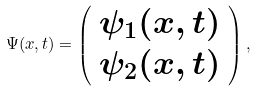Convert formula to latex. <formula><loc_0><loc_0><loc_500><loc_500>\Psi ( x , t ) = \left ( \begin{array} { c } \psi _ { 1 } ( x , t ) \\ \psi _ { 2 } ( x , t ) \end{array} \right ) ,</formula> 